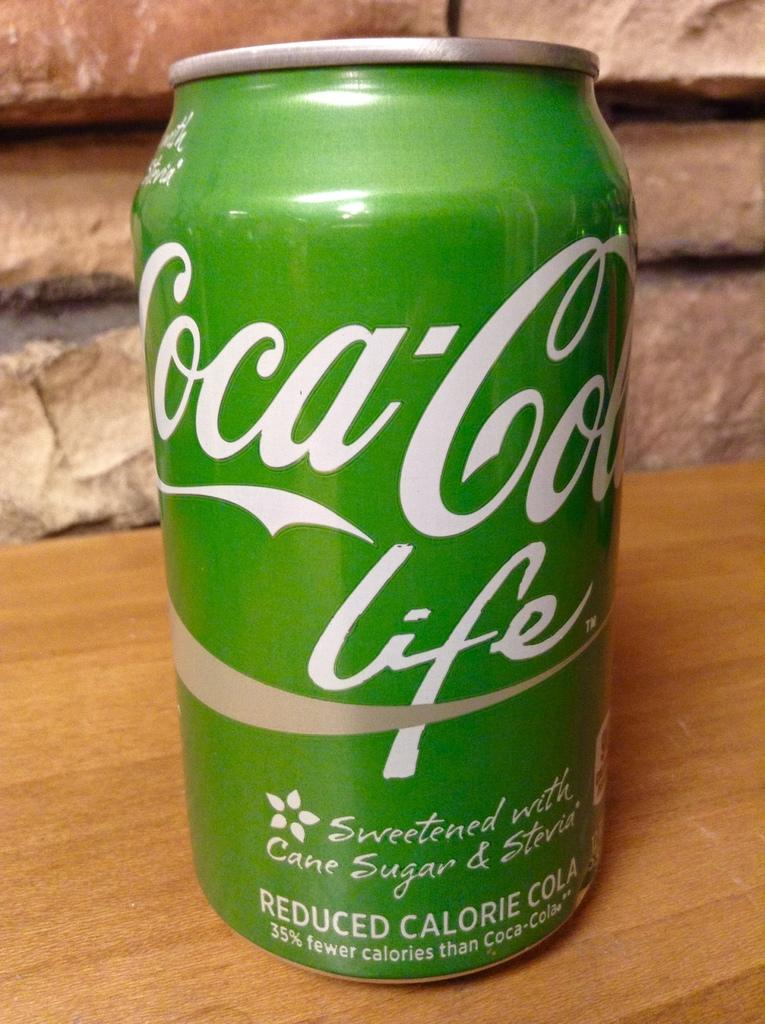Provide a one-sentence caption for the provided image. A green can of Coca-Cola Life written on it. 